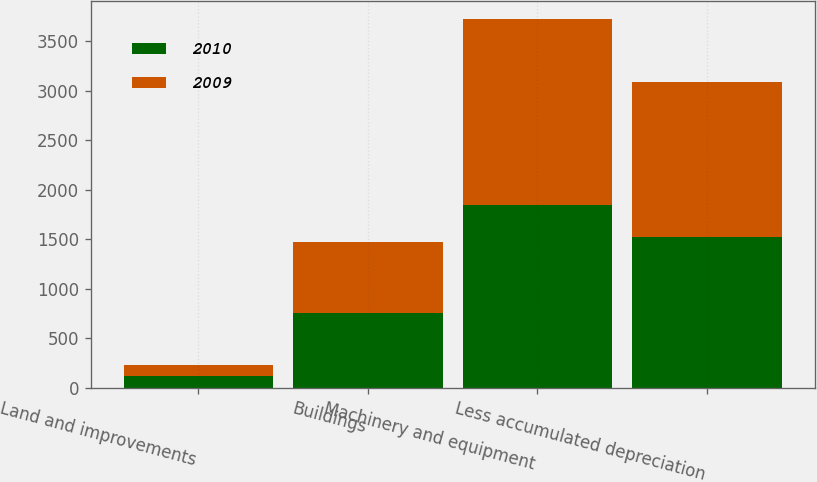<chart> <loc_0><loc_0><loc_500><loc_500><stacked_bar_chart><ecel><fcel>Land and improvements<fcel>Buildings<fcel>Machinery and equipment<fcel>Less accumulated depreciation<nl><fcel>2010<fcel>121.7<fcel>749<fcel>1844<fcel>1522.4<nl><fcel>2009<fcel>110.6<fcel>725.7<fcel>1877.6<fcel>1570.6<nl></chart> 